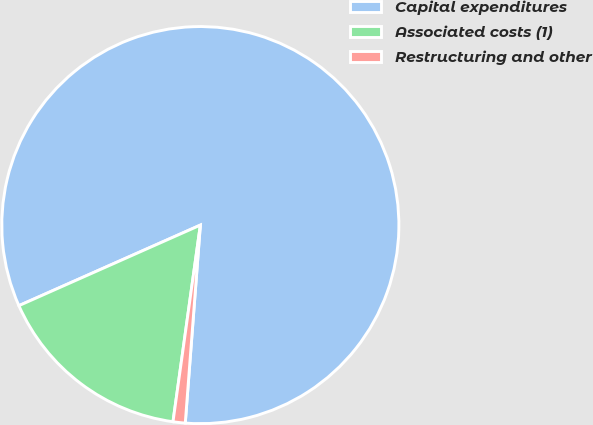<chart> <loc_0><loc_0><loc_500><loc_500><pie_chart><fcel>Capital expenditures<fcel>Associated costs (1)<fcel>Restructuring and other<nl><fcel>82.86%<fcel>16.15%<fcel>0.99%<nl></chart> 